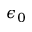Convert formula to latex. <formula><loc_0><loc_0><loc_500><loc_500>\epsilon _ { 0 }</formula> 